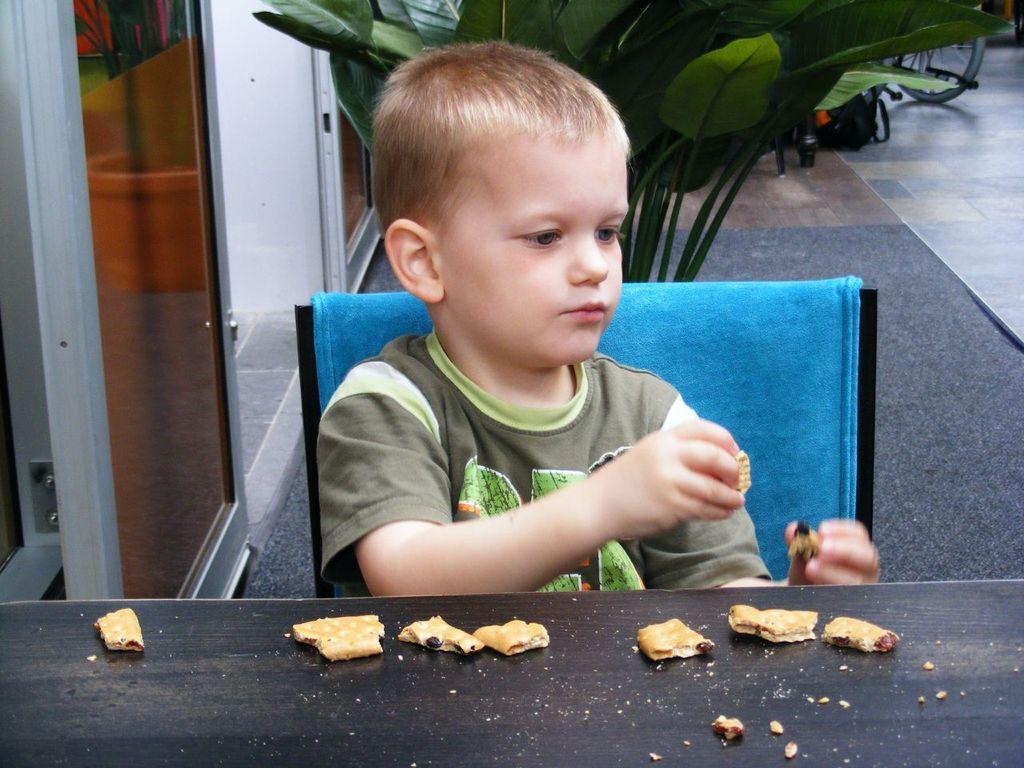Could you give a brief overview of what you see in this image? In this image there is a there is a table, on that table there are biscuit, behind the table there is a boy sitting on a chair, in the background there is a plant. 